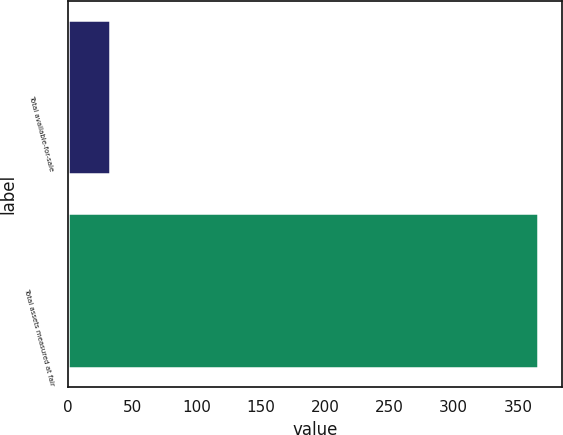Convert chart to OTSL. <chart><loc_0><loc_0><loc_500><loc_500><bar_chart><fcel>Total available-for-sale<fcel>Total assets measured at fair<nl><fcel>33<fcel>366<nl></chart> 